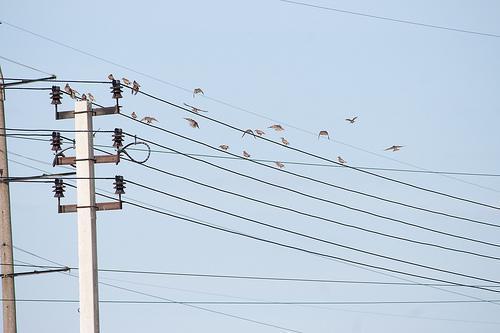How many poles are there?
Give a very brief answer. 2. How many dogs are sitting on the wires?
Give a very brief answer. 0. 